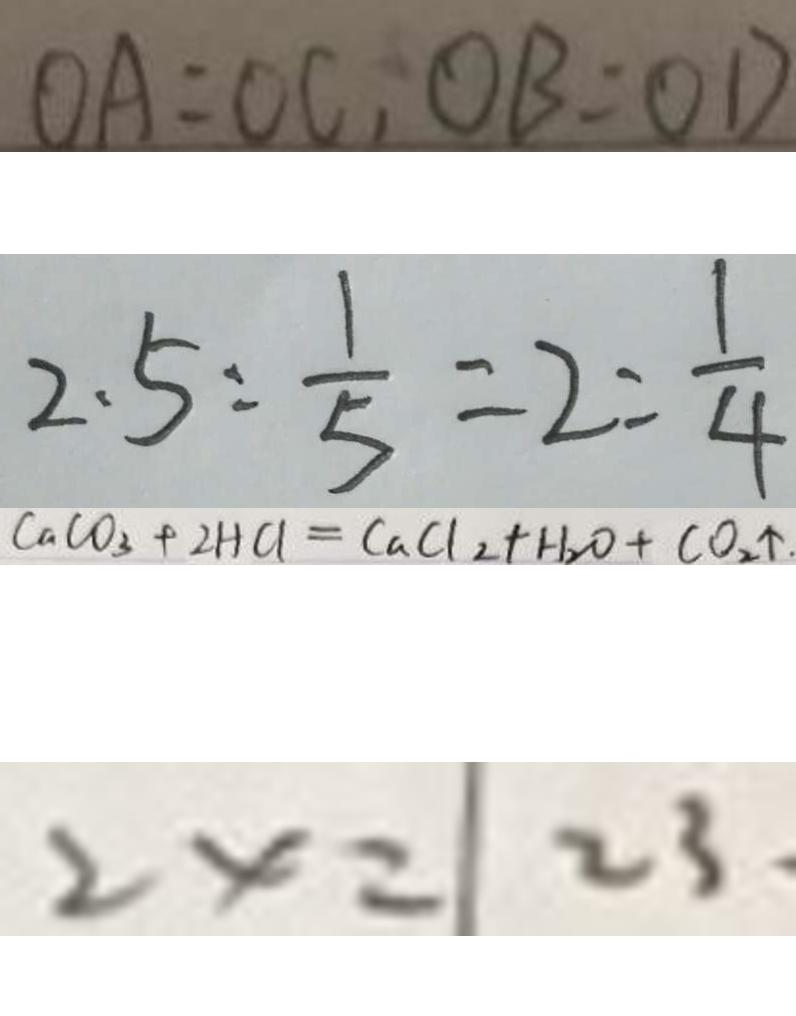<formula> <loc_0><loc_0><loc_500><loc_500>O A = O C , O B = O D 
 2 . 5 : \frac { 1 } { 5 } = 2 : \frac { 1 } { 4 } 
 C a C O _ { 3 } + 2 H C l _ { 2 } = C a C _ { 2 } + H _ { 2 } O + C O _ { 2 } \uparrow . 
 2 x = 2 3</formula> 